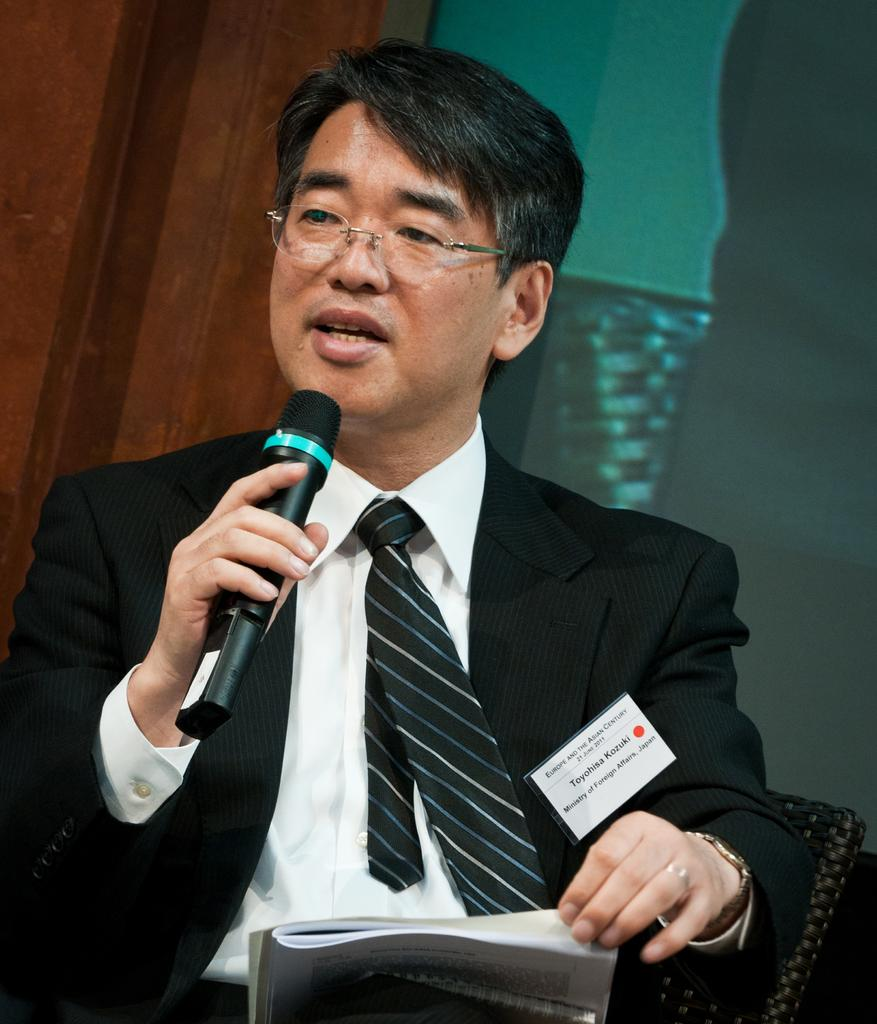What is the man in the image doing? The man is talking on a microphone. What can be seen on the man's face in the image? The man is wearing spectacles. What is the man wearing in the image? The man is wearing a black suit. What other object is present in the image? There is a book in the image. What type of fuel is being used by the man in the image? There is no mention of fuel in the image, as the man is talking on a microphone and not using any fuel. 